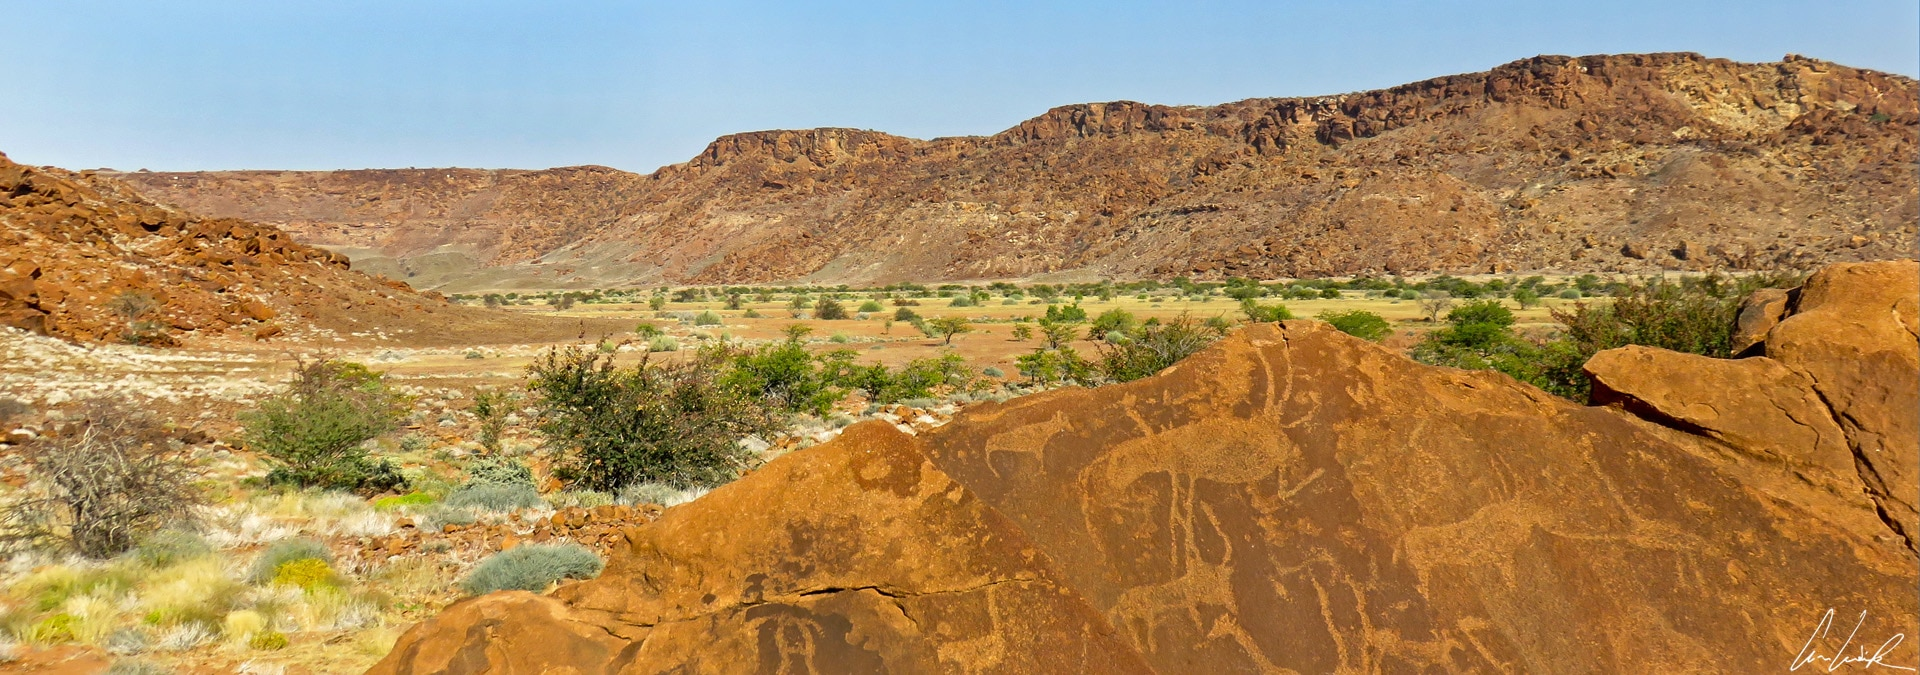Imagine a conversation between two ancient artists who created the engravings. What might they say about their work? Artist 1: *Look at this new engraving I've completed of the giraffes. I tried to capture their grace and the way they move across the plains.*

Artist 2: *It's wonderful! The lines are so fluid. I’ve just finished etching a scene of the hunt. I think it will tell our descendants about our way of life and the animals we revere.*

Artist 1: *Yes, it's important that we pass on these stories. These rocks will stand long after we are gone, bearing witness to our existence and our bond with nature.*

Artist 2: *Indeed, there’s something eternal about this work. Perhaps one day, people will come from beyond our horizon to marvel at what we've created here.* 